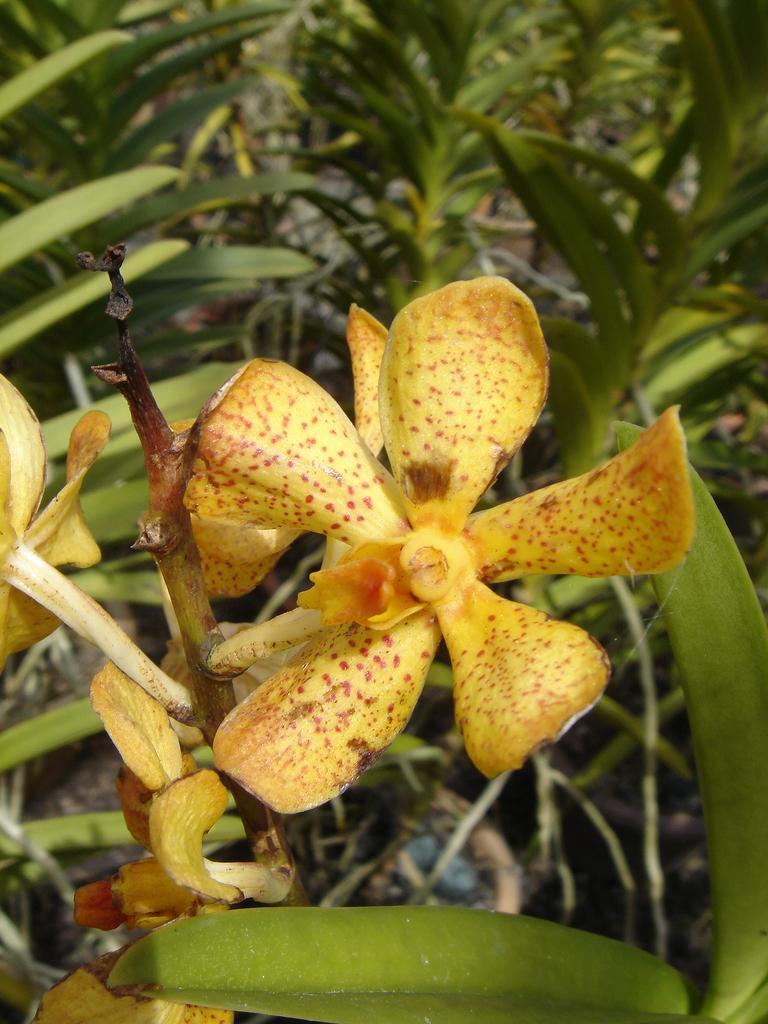Could you give a brief overview of what you see in this image? In this image we can see some flowers. At the bottom of the image there is a leaf. In the background of the image there are some leaves, branches and other objects. 